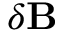Convert formula to latex. <formula><loc_0><loc_0><loc_500><loc_500>\delta B</formula> 